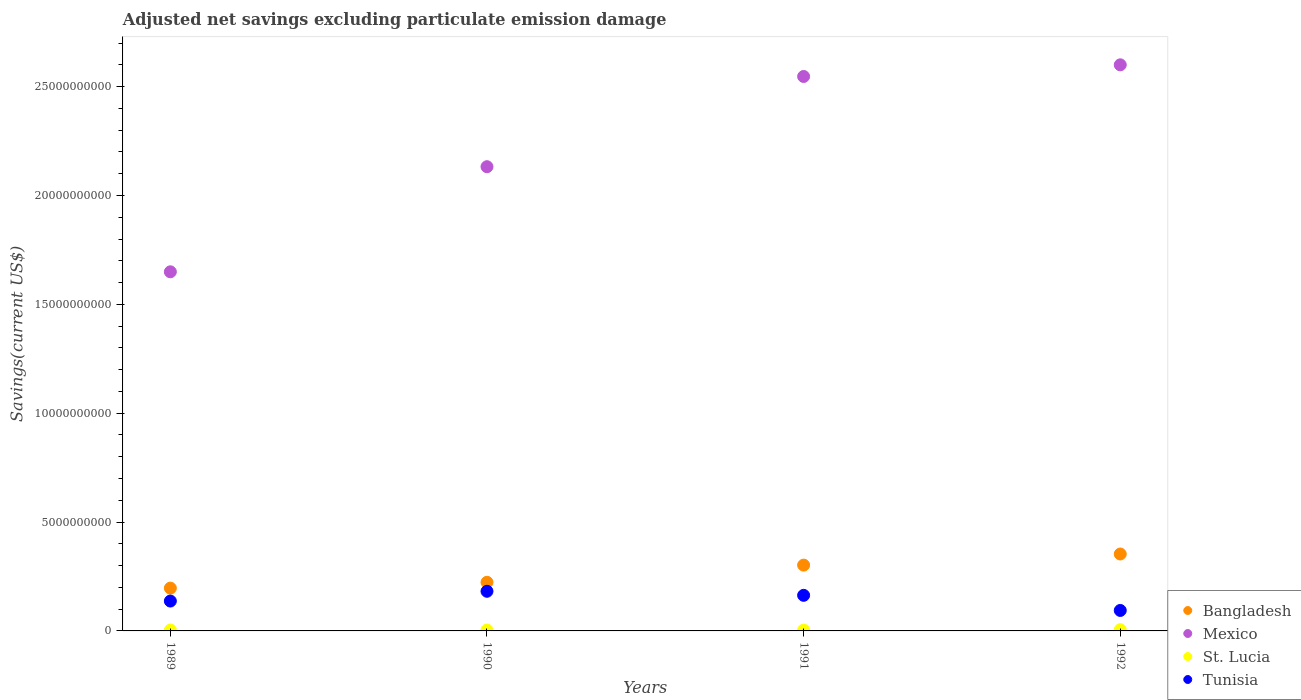How many different coloured dotlines are there?
Your response must be concise. 4. Is the number of dotlines equal to the number of legend labels?
Ensure brevity in your answer.  Yes. What is the adjusted net savings in Mexico in 1990?
Ensure brevity in your answer.  2.13e+1. Across all years, what is the maximum adjusted net savings in Bangladesh?
Give a very brief answer. 3.53e+09. Across all years, what is the minimum adjusted net savings in Mexico?
Keep it short and to the point. 1.65e+1. In which year was the adjusted net savings in Tunisia minimum?
Your answer should be compact. 1992. What is the total adjusted net savings in St. Lucia in the graph?
Give a very brief answer. 1.76e+08. What is the difference between the adjusted net savings in Mexico in 1989 and that in 1991?
Make the answer very short. -8.97e+09. What is the difference between the adjusted net savings in Mexico in 1991 and the adjusted net savings in St. Lucia in 1992?
Offer a terse response. 2.54e+1. What is the average adjusted net savings in St. Lucia per year?
Provide a succinct answer. 4.39e+07. In the year 1991, what is the difference between the adjusted net savings in Bangladesh and adjusted net savings in Tunisia?
Your response must be concise. 1.39e+09. In how many years, is the adjusted net savings in Mexico greater than 24000000000 US$?
Make the answer very short. 2. What is the ratio of the adjusted net savings in Bangladesh in 1989 to that in 1991?
Make the answer very short. 0.65. What is the difference between the highest and the second highest adjusted net savings in Mexico?
Offer a very short reply. 5.34e+08. What is the difference between the highest and the lowest adjusted net savings in Tunisia?
Your response must be concise. 8.81e+08. Is it the case that in every year, the sum of the adjusted net savings in Mexico and adjusted net savings in St. Lucia  is greater than the adjusted net savings in Bangladesh?
Make the answer very short. Yes. Is the adjusted net savings in Bangladesh strictly greater than the adjusted net savings in St. Lucia over the years?
Your answer should be compact. Yes. Does the graph contain grids?
Offer a very short reply. No. Where does the legend appear in the graph?
Your response must be concise. Bottom right. How many legend labels are there?
Provide a short and direct response. 4. What is the title of the graph?
Your response must be concise. Adjusted net savings excluding particulate emission damage. What is the label or title of the X-axis?
Offer a very short reply. Years. What is the label or title of the Y-axis?
Provide a succinct answer. Savings(current US$). What is the Savings(current US$) of Bangladesh in 1989?
Ensure brevity in your answer.  1.97e+09. What is the Savings(current US$) of Mexico in 1989?
Your answer should be very brief. 1.65e+1. What is the Savings(current US$) in St. Lucia in 1989?
Give a very brief answer. 4.16e+07. What is the Savings(current US$) in Tunisia in 1989?
Your response must be concise. 1.37e+09. What is the Savings(current US$) of Bangladesh in 1990?
Provide a short and direct response. 2.23e+09. What is the Savings(current US$) in Mexico in 1990?
Make the answer very short. 2.13e+1. What is the Savings(current US$) in St. Lucia in 1990?
Provide a succinct answer. 4.08e+07. What is the Savings(current US$) in Tunisia in 1990?
Your answer should be very brief. 1.82e+09. What is the Savings(current US$) in Bangladesh in 1991?
Your response must be concise. 3.02e+09. What is the Savings(current US$) in Mexico in 1991?
Keep it short and to the point. 2.55e+1. What is the Savings(current US$) in St. Lucia in 1991?
Offer a very short reply. 3.60e+07. What is the Savings(current US$) in Tunisia in 1991?
Your answer should be compact. 1.63e+09. What is the Savings(current US$) of Bangladesh in 1992?
Provide a short and direct response. 3.53e+09. What is the Savings(current US$) in Mexico in 1992?
Your answer should be very brief. 2.60e+1. What is the Savings(current US$) of St. Lucia in 1992?
Offer a very short reply. 5.72e+07. What is the Savings(current US$) in Tunisia in 1992?
Your answer should be very brief. 9.40e+08. Across all years, what is the maximum Savings(current US$) of Bangladesh?
Give a very brief answer. 3.53e+09. Across all years, what is the maximum Savings(current US$) in Mexico?
Keep it short and to the point. 2.60e+1. Across all years, what is the maximum Savings(current US$) in St. Lucia?
Ensure brevity in your answer.  5.72e+07. Across all years, what is the maximum Savings(current US$) in Tunisia?
Make the answer very short. 1.82e+09. Across all years, what is the minimum Savings(current US$) in Bangladesh?
Make the answer very short. 1.97e+09. Across all years, what is the minimum Savings(current US$) in Mexico?
Offer a terse response. 1.65e+1. Across all years, what is the minimum Savings(current US$) in St. Lucia?
Your response must be concise. 3.60e+07. Across all years, what is the minimum Savings(current US$) in Tunisia?
Offer a terse response. 9.40e+08. What is the total Savings(current US$) in Bangladesh in the graph?
Provide a succinct answer. 1.08e+1. What is the total Savings(current US$) of Mexico in the graph?
Provide a short and direct response. 8.93e+1. What is the total Savings(current US$) of St. Lucia in the graph?
Provide a short and direct response. 1.76e+08. What is the total Savings(current US$) of Tunisia in the graph?
Your response must be concise. 5.77e+09. What is the difference between the Savings(current US$) of Bangladesh in 1989 and that in 1990?
Your answer should be compact. -2.67e+08. What is the difference between the Savings(current US$) of Mexico in 1989 and that in 1990?
Keep it short and to the point. -4.83e+09. What is the difference between the Savings(current US$) in St. Lucia in 1989 and that in 1990?
Give a very brief answer. 7.75e+05. What is the difference between the Savings(current US$) in Tunisia in 1989 and that in 1990?
Give a very brief answer. -4.49e+08. What is the difference between the Savings(current US$) in Bangladesh in 1989 and that in 1991?
Offer a very short reply. -1.06e+09. What is the difference between the Savings(current US$) in Mexico in 1989 and that in 1991?
Offer a very short reply. -8.97e+09. What is the difference between the Savings(current US$) of St. Lucia in 1989 and that in 1991?
Your answer should be very brief. 5.59e+06. What is the difference between the Savings(current US$) of Tunisia in 1989 and that in 1991?
Provide a short and direct response. -2.63e+08. What is the difference between the Savings(current US$) in Bangladesh in 1989 and that in 1992?
Provide a succinct answer. -1.57e+09. What is the difference between the Savings(current US$) in Mexico in 1989 and that in 1992?
Make the answer very short. -9.51e+09. What is the difference between the Savings(current US$) in St. Lucia in 1989 and that in 1992?
Keep it short and to the point. -1.56e+07. What is the difference between the Savings(current US$) of Tunisia in 1989 and that in 1992?
Your answer should be compact. 4.31e+08. What is the difference between the Savings(current US$) in Bangladesh in 1990 and that in 1991?
Provide a succinct answer. -7.89e+08. What is the difference between the Savings(current US$) of Mexico in 1990 and that in 1991?
Your answer should be very brief. -4.14e+09. What is the difference between the Savings(current US$) in St. Lucia in 1990 and that in 1991?
Your answer should be very brief. 4.81e+06. What is the difference between the Savings(current US$) of Tunisia in 1990 and that in 1991?
Make the answer very short. 1.86e+08. What is the difference between the Savings(current US$) of Bangladesh in 1990 and that in 1992?
Your response must be concise. -1.30e+09. What is the difference between the Savings(current US$) of Mexico in 1990 and that in 1992?
Ensure brevity in your answer.  -4.68e+09. What is the difference between the Savings(current US$) in St. Lucia in 1990 and that in 1992?
Ensure brevity in your answer.  -1.63e+07. What is the difference between the Savings(current US$) in Tunisia in 1990 and that in 1992?
Offer a very short reply. 8.81e+08. What is the difference between the Savings(current US$) of Bangladesh in 1991 and that in 1992?
Make the answer very short. -5.11e+08. What is the difference between the Savings(current US$) of Mexico in 1991 and that in 1992?
Your response must be concise. -5.34e+08. What is the difference between the Savings(current US$) of St. Lucia in 1991 and that in 1992?
Your answer should be compact. -2.11e+07. What is the difference between the Savings(current US$) of Tunisia in 1991 and that in 1992?
Your answer should be compact. 6.95e+08. What is the difference between the Savings(current US$) in Bangladesh in 1989 and the Savings(current US$) in Mexico in 1990?
Make the answer very short. -1.94e+1. What is the difference between the Savings(current US$) of Bangladesh in 1989 and the Savings(current US$) of St. Lucia in 1990?
Your answer should be very brief. 1.93e+09. What is the difference between the Savings(current US$) in Bangladesh in 1989 and the Savings(current US$) in Tunisia in 1990?
Your response must be concise. 1.45e+08. What is the difference between the Savings(current US$) in Mexico in 1989 and the Savings(current US$) in St. Lucia in 1990?
Make the answer very short. 1.65e+1. What is the difference between the Savings(current US$) of Mexico in 1989 and the Savings(current US$) of Tunisia in 1990?
Keep it short and to the point. 1.47e+1. What is the difference between the Savings(current US$) of St. Lucia in 1989 and the Savings(current US$) of Tunisia in 1990?
Provide a succinct answer. -1.78e+09. What is the difference between the Savings(current US$) in Bangladesh in 1989 and the Savings(current US$) in Mexico in 1991?
Offer a terse response. -2.35e+1. What is the difference between the Savings(current US$) in Bangladesh in 1989 and the Savings(current US$) in St. Lucia in 1991?
Offer a terse response. 1.93e+09. What is the difference between the Savings(current US$) of Bangladesh in 1989 and the Savings(current US$) of Tunisia in 1991?
Make the answer very short. 3.31e+08. What is the difference between the Savings(current US$) of Mexico in 1989 and the Savings(current US$) of St. Lucia in 1991?
Your response must be concise. 1.65e+1. What is the difference between the Savings(current US$) in Mexico in 1989 and the Savings(current US$) in Tunisia in 1991?
Offer a very short reply. 1.49e+1. What is the difference between the Savings(current US$) of St. Lucia in 1989 and the Savings(current US$) of Tunisia in 1991?
Your answer should be compact. -1.59e+09. What is the difference between the Savings(current US$) of Bangladesh in 1989 and the Savings(current US$) of Mexico in 1992?
Your response must be concise. -2.40e+1. What is the difference between the Savings(current US$) of Bangladesh in 1989 and the Savings(current US$) of St. Lucia in 1992?
Provide a short and direct response. 1.91e+09. What is the difference between the Savings(current US$) of Bangladesh in 1989 and the Savings(current US$) of Tunisia in 1992?
Keep it short and to the point. 1.03e+09. What is the difference between the Savings(current US$) in Mexico in 1989 and the Savings(current US$) in St. Lucia in 1992?
Offer a terse response. 1.64e+1. What is the difference between the Savings(current US$) in Mexico in 1989 and the Savings(current US$) in Tunisia in 1992?
Make the answer very short. 1.56e+1. What is the difference between the Savings(current US$) in St. Lucia in 1989 and the Savings(current US$) in Tunisia in 1992?
Your response must be concise. -8.99e+08. What is the difference between the Savings(current US$) of Bangladesh in 1990 and the Savings(current US$) of Mexico in 1991?
Your answer should be very brief. -2.32e+1. What is the difference between the Savings(current US$) of Bangladesh in 1990 and the Savings(current US$) of St. Lucia in 1991?
Keep it short and to the point. 2.20e+09. What is the difference between the Savings(current US$) in Bangladesh in 1990 and the Savings(current US$) in Tunisia in 1991?
Offer a terse response. 5.98e+08. What is the difference between the Savings(current US$) in Mexico in 1990 and the Savings(current US$) in St. Lucia in 1991?
Your response must be concise. 2.13e+1. What is the difference between the Savings(current US$) in Mexico in 1990 and the Savings(current US$) in Tunisia in 1991?
Your answer should be compact. 1.97e+1. What is the difference between the Savings(current US$) of St. Lucia in 1990 and the Savings(current US$) of Tunisia in 1991?
Offer a very short reply. -1.59e+09. What is the difference between the Savings(current US$) in Bangladesh in 1990 and the Savings(current US$) in Mexico in 1992?
Keep it short and to the point. -2.38e+1. What is the difference between the Savings(current US$) in Bangladesh in 1990 and the Savings(current US$) in St. Lucia in 1992?
Ensure brevity in your answer.  2.18e+09. What is the difference between the Savings(current US$) of Bangladesh in 1990 and the Savings(current US$) of Tunisia in 1992?
Give a very brief answer. 1.29e+09. What is the difference between the Savings(current US$) of Mexico in 1990 and the Savings(current US$) of St. Lucia in 1992?
Your response must be concise. 2.13e+1. What is the difference between the Savings(current US$) in Mexico in 1990 and the Savings(current US$) in Tunisia in 1992?
Provide a succinct answer. 2.04e+1. What is the difference between the Savings(current US$) in St. Lucia in 1990 and the Savings(current US$) in Tunisia in 1992?
Your response must be concise. -8.99e+08. What is the difference between the Savings(current US$) in Bangladesh in 1991 and the Savings(current US$) in Mexico in 1992?
Your answer should be very brief. -2.30e+1. What is the difference between the Savings(current US$) in Bangladesh in 1991 and the Savings(current US$) in St. Lucia in 1992?
Offer a very short reply. 2.96e+09. What is the difference between the Savings(current US$) in Bangladesh in 1991 and the Savings(current US$) in Tunisia in 1992?
Your answer should be compact. 2.08e+09. What is the difference between the Savings(current US$) in Mexico in 1991 and the Savings(current US$) in St. Lucia in 1992?
Provide a succinct answer. 2.54e+1. What is the difference between the Savings(current US$) in Mexico in 1991 and the Savings(current US$) in Tunisia in 1992?
Your answer should be very brief. 2.45e+1. What is the difference between the Savings(current US$) of St. Lucia in 1991 and the Savings(current US$) of Tunisia in 1992?
Keep it short and to the point. -9.04e+08. What is the average Savings(current US$) in Bangladesh per year?
Offer a terse response. 2.69e+09. What is the average Savings(current US$) in Mexico per year?
Your answer should be very brief. 2.23e+1. What is the average Savings(current US$) of St. Lucia per year?
Ensure brevity in your answer.  4.39e+07. What is the average Savings(current US$) in Tunisia per year?
Keep it short and to the point. 1.44e+09. In the year 1989, what is the difference between the Savings(current US$) of Bangladesh and Savings(current US$) of Mexico?
Keep it short and to the point. -1.45e+1. In the year 1989, what is the difference between the Savings(current US$) in Bangladesh and Savings(current US$) in St. Lucia?
Keep it short and to the point. 1.92e+09. In the year 1989, what is the difference between the Savings(current US$) of Bangladesh and Savings(current US$) of Tunisia?
Offer a very short reply. 5.94e+08. In the year 1989, what is the difference between the Savings(current US$) of Mexico and Savings(current US$) of St. Lucia?
Your answer should be compact. 1.65e+1. In the year 1989, what is the difference between the Savings(current US$) in Mexico and Savings(current US$) in Tunisia?
Ensure brevity in your answer.  1.51e+1. In the year 1989, what is the difference between the Savings(current US$) in St. Lucia and Savings(current US$) in Tunisia?
Give a very brief answer. -1.33e+09. In the year 1990, what is the difference between the Savings(current US$) of Bangladesh and Savings(current US$) of Mexico?
Make the answer very short. -1.91e+1. In the year 1990, what is the difference between the Savings(current US$) of Bangladesh and Savings(current US$) of St. Lucia?
Offer a terse response. 2.19e+09. In the year 1990, what is the difference between the Savings(current US$) of Bangladesh and Savings(current US$) of Tunisia?
Make the answer very short. 4.12e+08. In the year 1990, what is the difference between the Savings(current US$) in Mexico and Savings(current US$) in St. Lucia?
Make the answer very short. 2.13e+1. In the year 1990, what is the difference between the Savings(current US$) of Mexico and Savings(current US$) of Tunisia?
Your answer should be very brief. 1.95e+1. In the year 1990, what is the difference between the Savings(current US$) of St. Lucia and Savings(current US$) of Tunisia?
Ensure brevity in your answer.  -1.78e+09. In the year 1991, what is the difference between the Savings(current US$) of Bangladesh and Savings(current US$) of Mexico?
Keep it short and to the point. -2.24e+1. In the year 1991, what is the difference between the Savings(current US$) in Bangladesh and Savings(current US$) in St. Lucia?
Your answer should be compact. 2.99e+09. In the year 1991, what is the difference between the Savings(current US$) in Bangladesh and Savings(current US$) in Tunisia?
Your answer should be compact. 1.39e+09. In the year 1991, what is the difference between the Savings(current US$) in Mexico and Savings(current US$) in St. Lucia?
Keep it short and to the point. 2.54e+1. In the year 1991, what is the difference between the Savings(current US$) in Mexico and Savings(current US$) in Tunisia?
Ensure brevity in your answer.  2.38e+1. In the year 1991, what is the difference between the Savings(current US$) of St. Lucia and Savings(current US$) of Tunisia?
Offer a very short reply. -1.60e+09. In the year 1992, what is the difference between the Savings(current US$) of Bangladesh and Savings(current US$) of Mexico?
Make the answer very short. -2.25e+1. In the year 1992, what is the difference between the Savings(current US$) of Bangladesh and Savings(current US$) of St. Lucia?
Keep it short and to the point. 3.48e+09. In the year 1992, what is the difference between the Savings(current US$) of Bangladesh and Savings(current US$) of Tunisia?
Your response must be concise. 2.59e+09. In the year 1992, what is the difference between the Savings(current US$) of Mexico and Savings(current US$) of St. Lucia?
Make the answer very short. 2.59e+1. In the year 1992, what is the difference between the Savings(current US$) of Mexico and Savings(current US$) of Tunisia?
Offer a terse response. 2.51e+1. In the year 1992, what is the difference between the Savings(current US$) in St. Lucia and Savings(current US$) in Tunisia?
Provide a short and direct response. -8.83e+08. What is the ratio of the Savings(current US$) in Bangladesh in 1989 to that in 1990?
Your answer should be very brief. 0.88. What is the ratio of the Savings(current US$) of Mexico in 1989 to that in 1990?
Make the answer very short. 0.77. What is the ratio of the Savings(current US$) of St. Lucia in 1989 to that in 1990?
Make the answer very short. 1.02. What is the ratio of the Savings(current US$) of Tunisia in 1989 to that in 1990?
Your answer should be very brief. 0.75. What is the ratio of the Savings(current US$) in Bangladesh in 1989 to that in 1991?
Your answer should be compact. 0.65. What is the ratio of the Savings(current US$) of Mexico in 1989 to that in 1991?
Your answer should be very brief. 0.65. What is the ratio of the Savings(current US$) in St. Lucia in 1989 to that in 1991?
Your answer should be compact. 1.16. What is the ratio of the Savings(current US$) in Tunisia in 1989 to that in 1991?
Your answer should be very brief. 0.84. What is the ratio of the Savings(current US$) in Bangladesh in 1989 to that in 1992?
Offer a very short reply. 0.56. What is the ratio of the Savings(current US$) of Mexico in 1989 to that in 1992?
Give a very brief answer. 0.63. What is the ratio of the Savings(current US$) of St. Lucia in 1989 to that in 1992?
Offer a terse response. 0.73. What is the ratio of the Savings(current US$) of Tunisia in 1989 to that in 1992?
Make the answer very short. 1.46. What is the ratio of the Savings(current US$) in Bangladesh in 1990 to that in 1991?
Make the answer very short. 0.74. What is the ratio of the Savings(current US$) of Mexico in 1990 to that in 1991?
Offer a terse response. 0.84. What is the ratio of the Savings(current US$) in St. Lucia in 1990 to that in 1991?
Offer a very short reply. 1.13. What is the ratio of the Savings(current US$) in Tunisia in 1990 to that in 1991?
Provide a short and direct response. 1.11. What is the ratio of the Savings(current US$) of Bangladesh in 1990 to that in 1992?
Provide a short and direct response. 0.63. What is the ratio of the Savings(current US$) of Mexico in 1990 to that in 1992?
Keep it short and to the point. 0.82. What is the ratio of the Savings(current US$) in Tunisia in 1990 to that in 1992?
Your answer should be very brief. 1.94. What is the ratio of the Savings(current US$) in Bangladesh in 1991 to that in 1992?
Your answer should be compact. 0.86. What is the ratio of the Savings(current US$) of Mexico in 1991 to that in 1992?
Ensure brevity in your answer.  0.98. What is the ratio of the Savings(current US$) of St. Lucia in 1991 to that in 1992?
Keep it short and to the point. 0.63. What is the ratio of the Savings(current US$) of Tunisia in 1991 to that in 1992?
Make the answer very short. 1.74. What is the difference between the highest and the second highest Savings(current US$) of Bangladesh?
Offer a terse response. 5.11e+08. What is the difference between the highest and the second highest Savings(current US$) of Mexico?
Give a very brief answer. 5.34e+08. What is the difference between the highest and the second highest Savings(current US$) in St. Lucia?
Your answer should be compact. 1.56e+07. What is the difference between the highest and the second highest Savings(current US$) in Tunisia?
Provide a short and direct response. 1.86e+08. What is the difference between the highest and the lowest Savings(current US$) in Bangladesh?
Keep it short and to the point. 1.57e+09. What is the difference between the highest and the lowest Savings(current US$) of Mexico?
Your response must be concise. 9.51e+09. What is the difference between the highest and the lowest Savings(current US$) in St. Lucia?
Your response must be concise. 2.11e+07. What is the difference between the highest and the lowest Savings(current US$) in Tunisia?
Your response must be concise. 8.81e+08. 